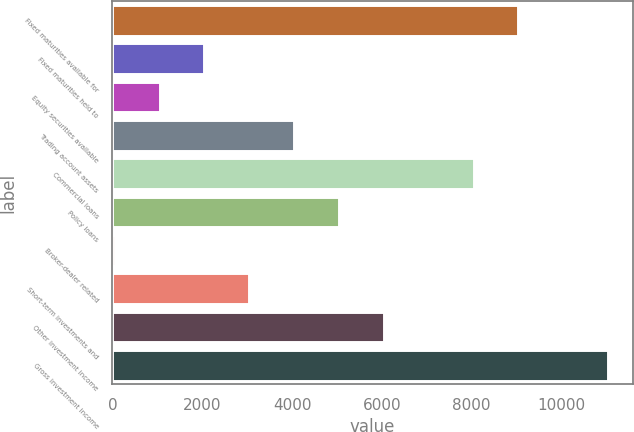<chart> <loc_0><loc_0><loc_500><loc_500><bar_chart><fcel>Fixed maturities available for<fcel>Fixed maturities held to<fcel>Equity securities available<fcel>Trading account assets<fcel>Commercial loans<fcel>Policy loans<fcel>Broker-dealer related<fcel>Short-term investments and<fcel>Other investment income<fcel>Gross investment income<nl><fcel>9043.9<fcel>2050.2<fcel>1051.1<fcel>4048.4<fcel>8044.8<fcel>5047.5<fcel>52<fcel>3049.3<fcel>6046.6<fcel>11042.1<nl></chart> 